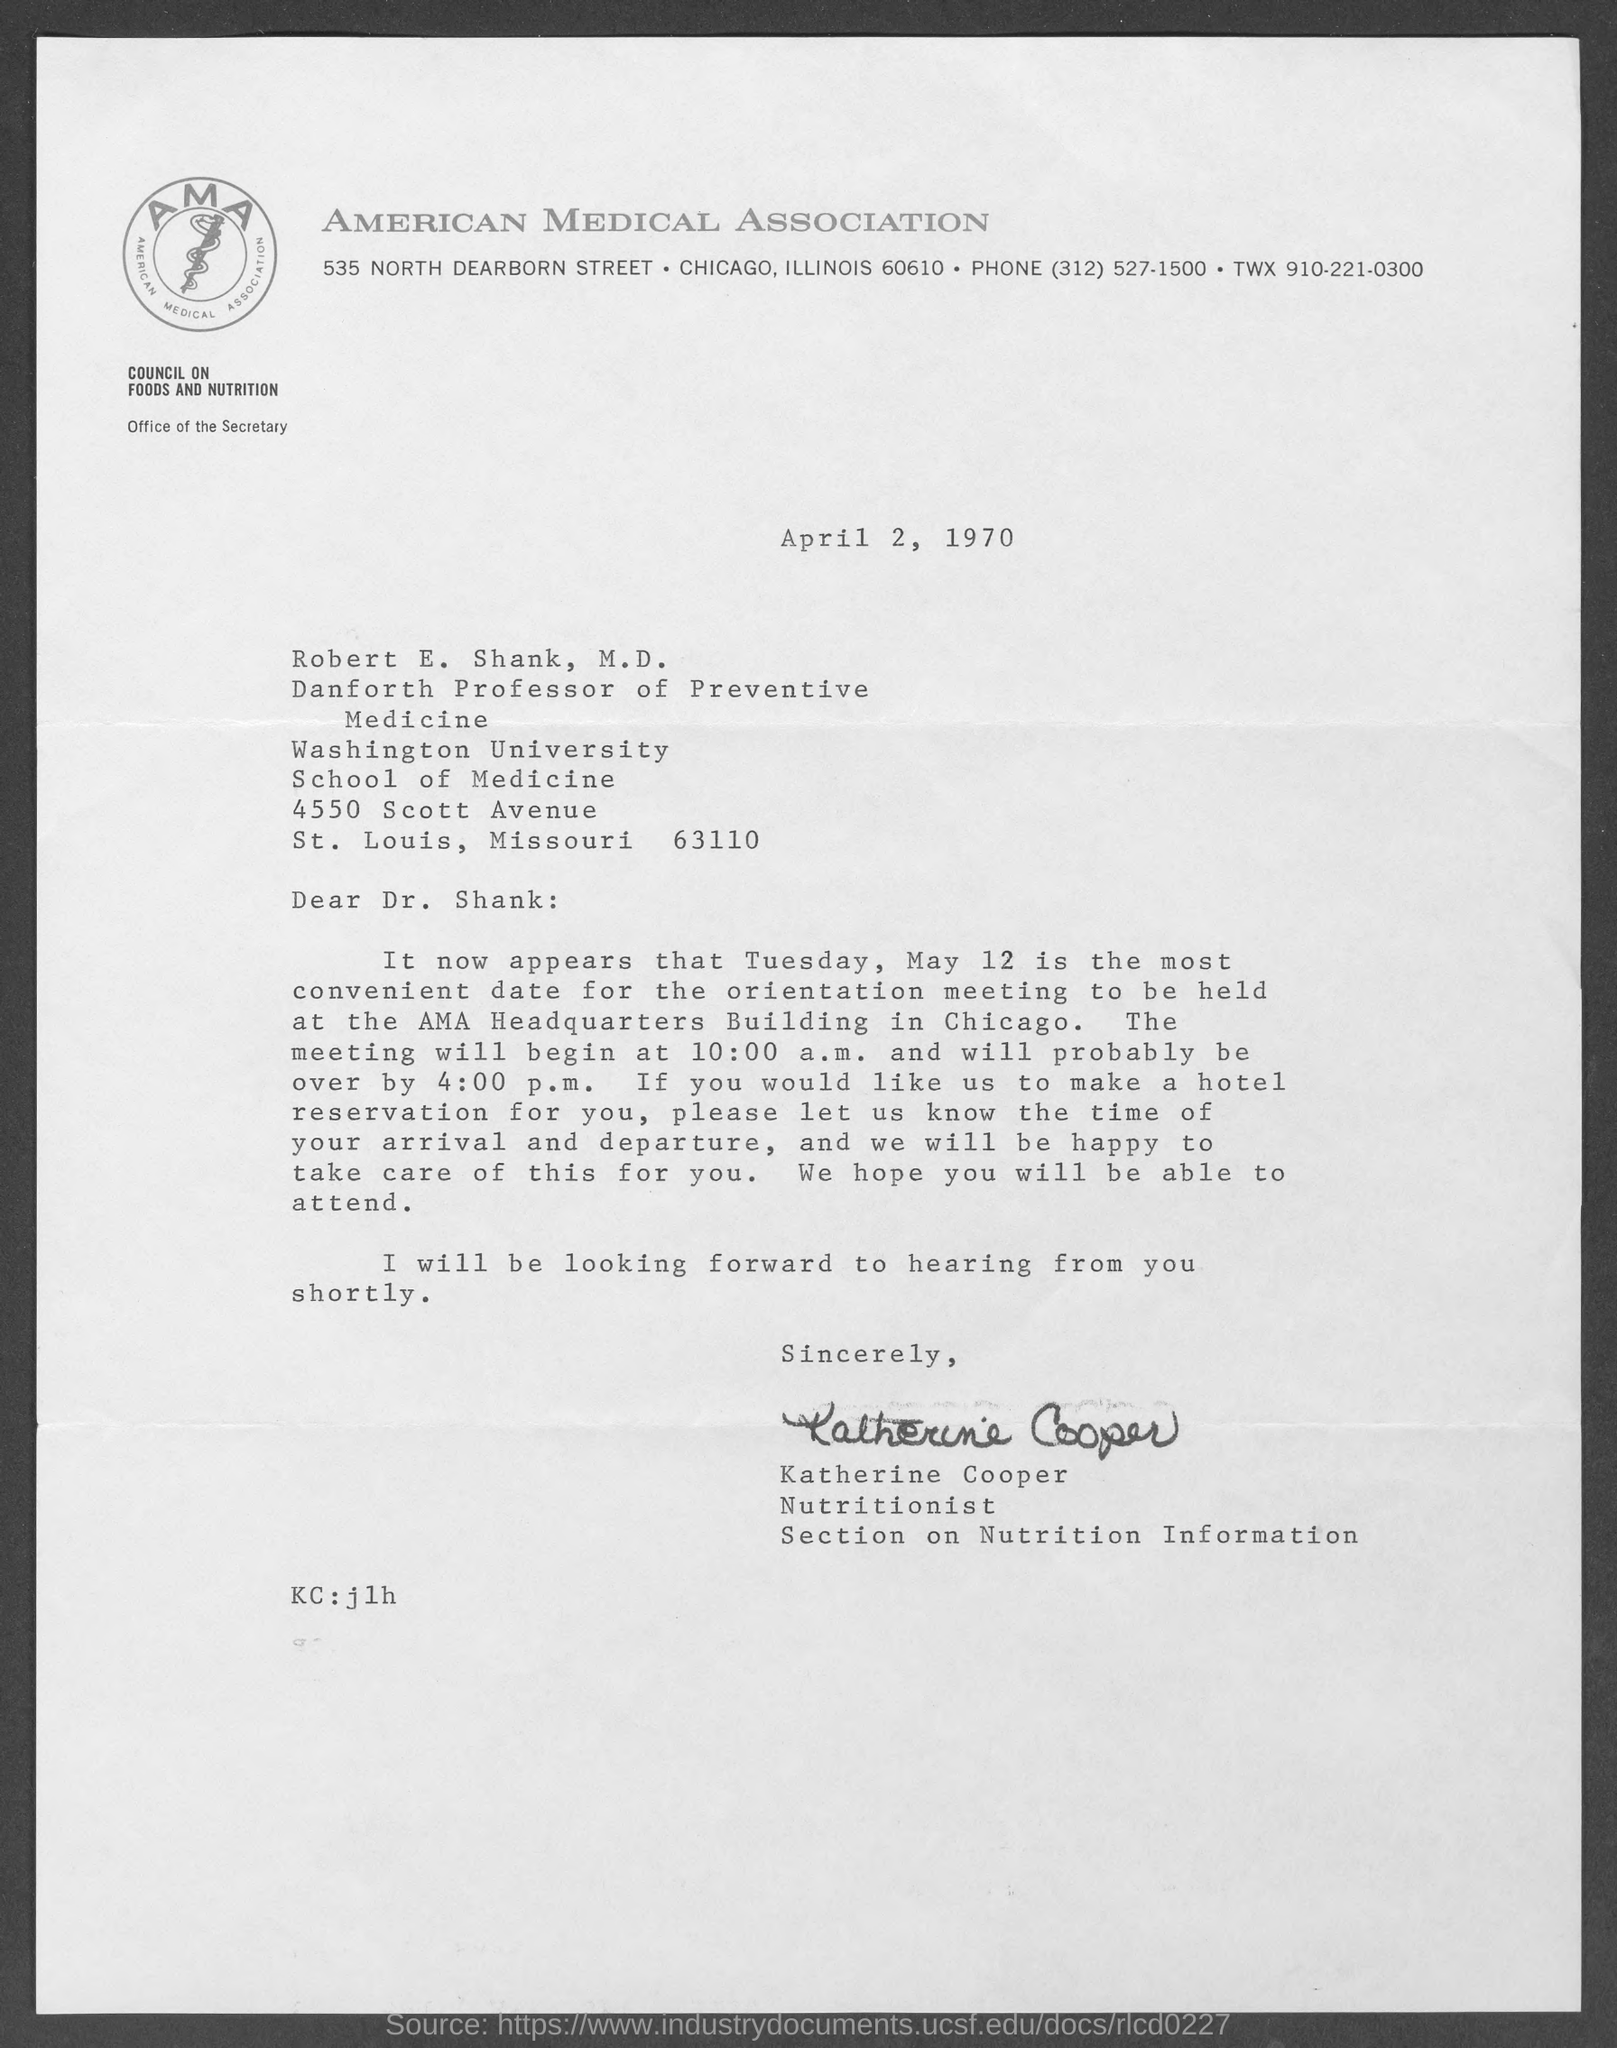Specify some key components in this picture. The document is dated April 2, 1970. The phone number of the American Medical Association is (312) 527-1500. The American Medical Association is mentioned. The orientation meeting will be held at the AMA Headquarters Building in Chicago. 